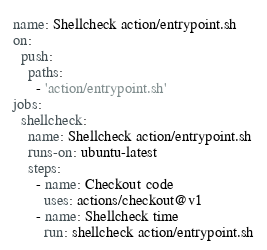<code> <loc_0><loc_0><loc_500><loc_500><_YAML_>name: Shellcheck action/entrypoint.sh
on:
  push:
    paths:
      - 'action/entrypoint.sh'
jobs:
  shellcheck:
    name: Shellcheck action/entrypoint.sh
    runs-on: ubuntu-latest
    steps:
      - name: Checkout code
        uses: actions/checkout@v1
      - name: Shellcheck time
        run: shellcheck action/entrypoint.sh
</code> 